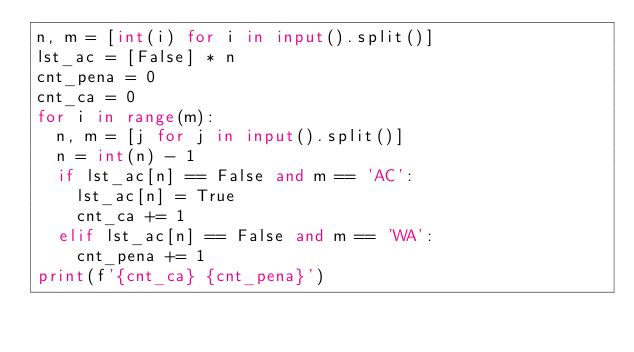<code> <loc_0><loc_0><loc_500><loc_500><_Python_>n, m = [int(i) for i in input().split()]
lst_ac = [False] * n
cnt_pena = 0
cnt_ca = 0
for i in range(m):
	n, m = [j for j in input().split()]
	n = int(n) - 1
	if lst_ac[n] == False and m == 'AC':
		lst_ac[n] = True
		cnt_ca += 1
	elif lst_ac[n] == False and m == 'WA':
		cnt_pena += 1
print(f'{cnt_ca} {cnt_pena}')</code> 